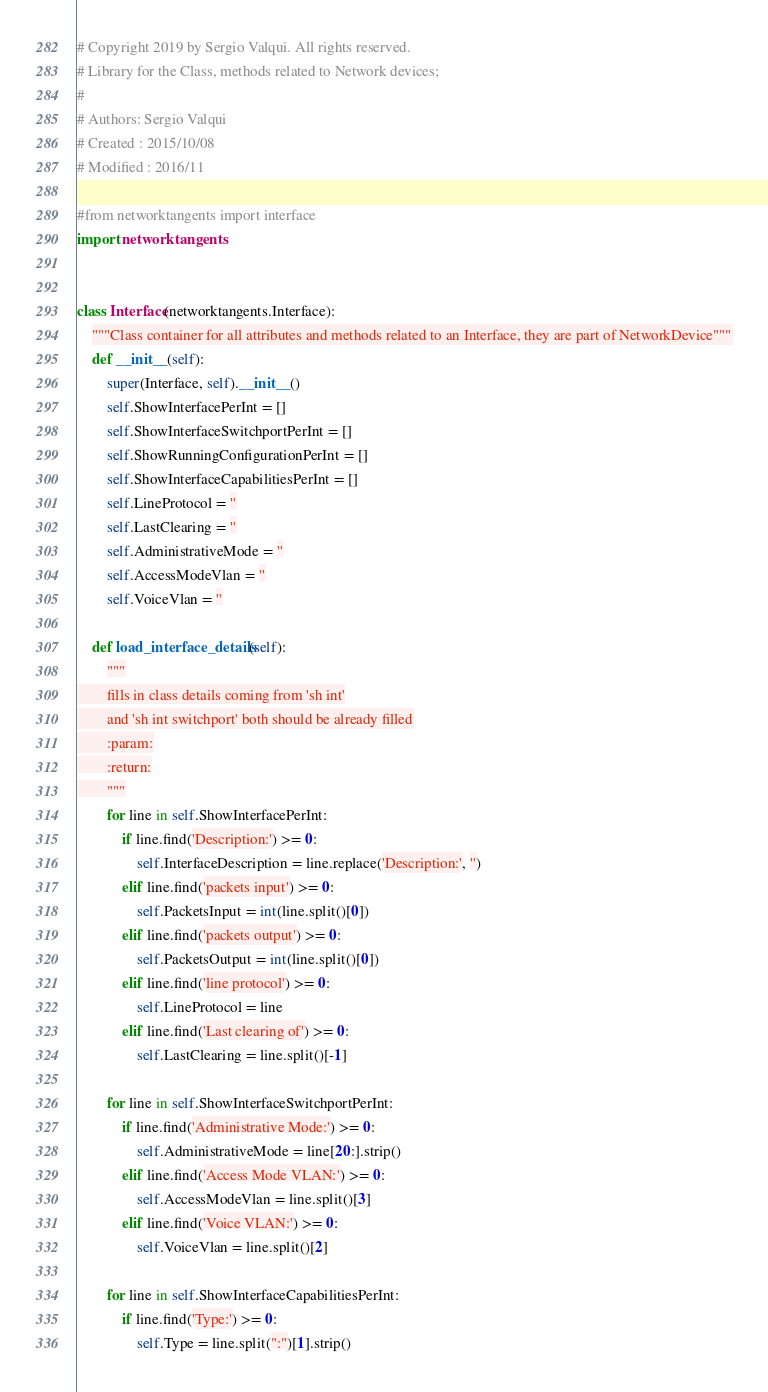<code> <loc_0><loc_0><loc_500><loc_500><_Python_># Copyright 2019 by Sergio Valqui. All rights reserved.
# Library for the Class, methods related to Network devices;
#
# Authors: Sergio Valqui
# Created : 2015/10/08
# Modified : 2016/11

#from networktangents import interface
import networktangents


class Interface(networktangents.Interface):
    """Class container for all attributes and methods related to an Interface, they are part of NetworkDevice"""
    def __init__(self):
        super(Interface, self).__init__()
        self.ShowInterfacePerInt = []
        self.ShowInterfaceSwitchportPerInt = []
        self.ShowRunningConfigurationPerInt = []
        self.ShowInterfaceCapabilitiesPerInt = []
        self.LineProtocol = ''
        self.LastClearing = ''
        self.AdministrativeMode = ''
        self.AccessModeVlan = ''
        self.VoiceVlan = ''

    def load_interface_details(self):
        """
        fills in class details coming from 'sh int'
        and 'sh int switchport' both should be already filled
        :param:
        :return:
        """
        for line in self.ShowInterfacePerInt:
            if line.find('Description:') >= 0:
                self.InterfaceDescription = line.replace('Description:', '')
            elif line.find('packets input') >= 0:
                self.PacketsInput = int(line.split()[0])
            elif line.find('packets output') >= 0:
                self.PacketsOutput = int(line.split()[0])
            elif line.find('line protocol') >= 0:
                self.LineProtocol = line
            elif line.find('Last clearing of') >= 0:
                self.LastClearing = line.split()[-1]

        for line in self.ShowInterfaceSwitchportPerInt:
            if line.find('Administrative Mode:') >= 0:
                self.AdministrativeMode = line[20:].strip()
            elif line.find('Access Mode VLAN:') >= 0:
                self.AccessModeVlan = line.split()[3]
            elif line.find('Voice VLAN:') >= 0:
                self.VoiceVlan = line.split()[2]

        for line in self.ShowInterfaceCapabilitiesPerInt:
            if line.find('Type:') >= 0:
                self.Type = line.split(":")[1].strip()
</code> 